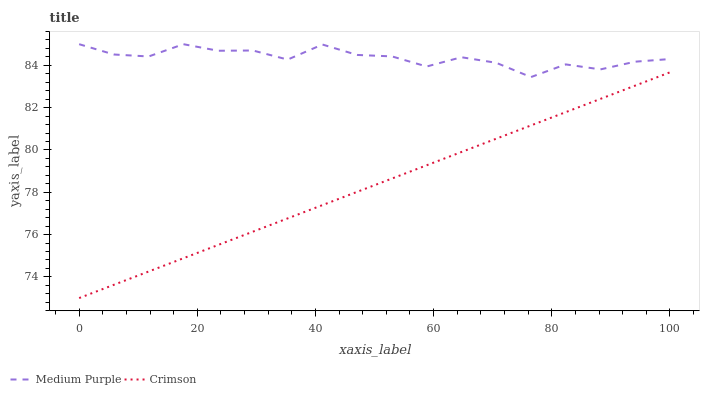Does Crimson have the minimum area under the curve?
Answer yes or no. Yes. Does Medium Purple have the maximum area under the curve?
Answer yes or no. Yes. Does Crimson have the maximum area under the curve?
Answer yes or no. No. Is Crimson the smoothest?
Answer yes or no. Yes. Is Medium Purple the roughest?
Answer yes or no. Yes. Is Crimson the roughest?
Answer yes or no. No. Does Medium Purple have the highest value?
Answer yes or no. Yes. Does Crimson have the highest value?
Answer yes or no. No. Is Crimson less than Medium Purple?
Answer yes or no. Yes. Is Medium Purple greater than Crimson?
Answer yes or no. Yes. Does Crimson intersect Medium Purple?
Answer yes or no. No. 